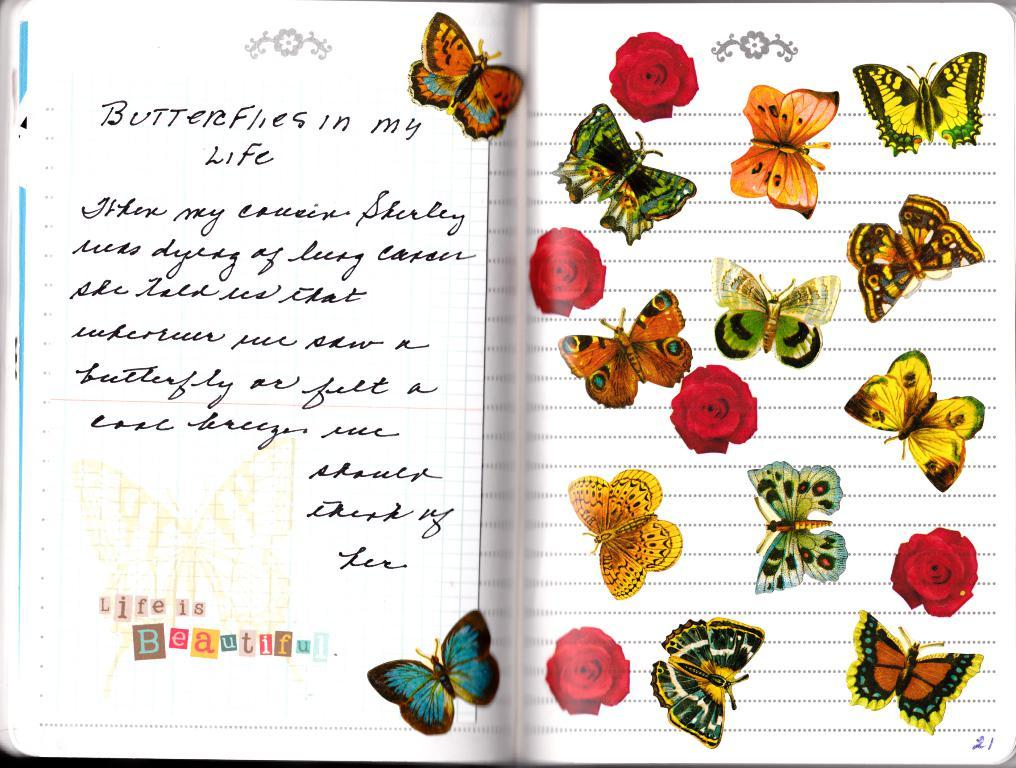What is the main object in the image? There is a book in the image. What can be found on the book? The book has text on it and stickers of butterflies and flowers. Can you see the grandmother looking at the book from an angle in the image? There is no grandmother or any person present in the image; it only features a book with text and stickers. 